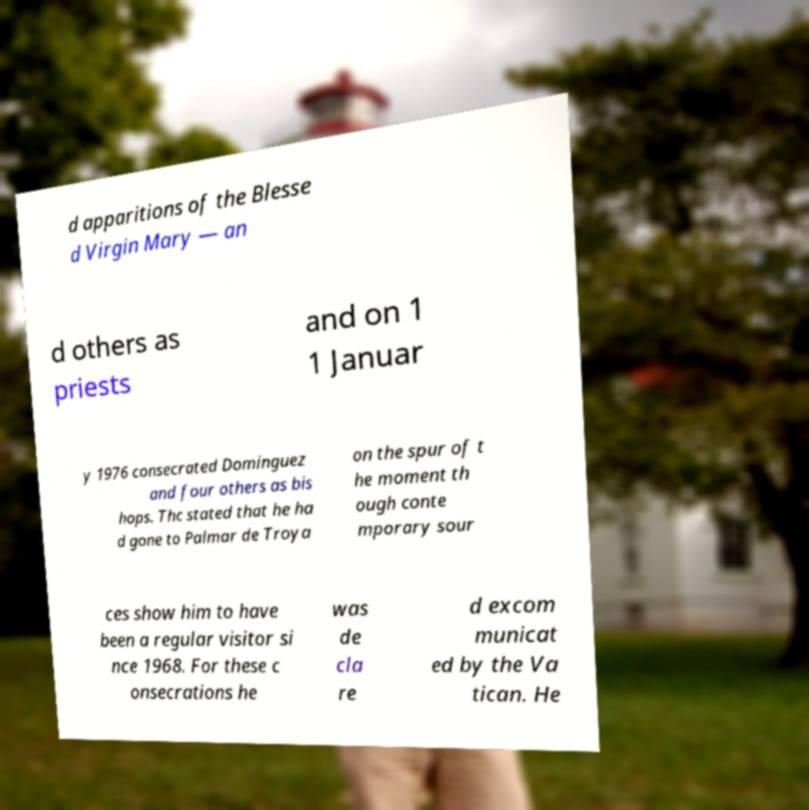Could you assist in decoding the text presented in this image and type it out clearly? d apparitions of the Blesse d Virgin Mary — an d others as priests and on 1 1 Januar y 1976 consecrated Dominguez and four others as bis hops. Thc stated that he ha d gone to Palmar de Troya on the spur of t he moment th ough conte mporary sour ces show him to have been a regular visitor si nce 1968. For these c onsecrations he was de cla re d excom municat ed by the Va tican. He 